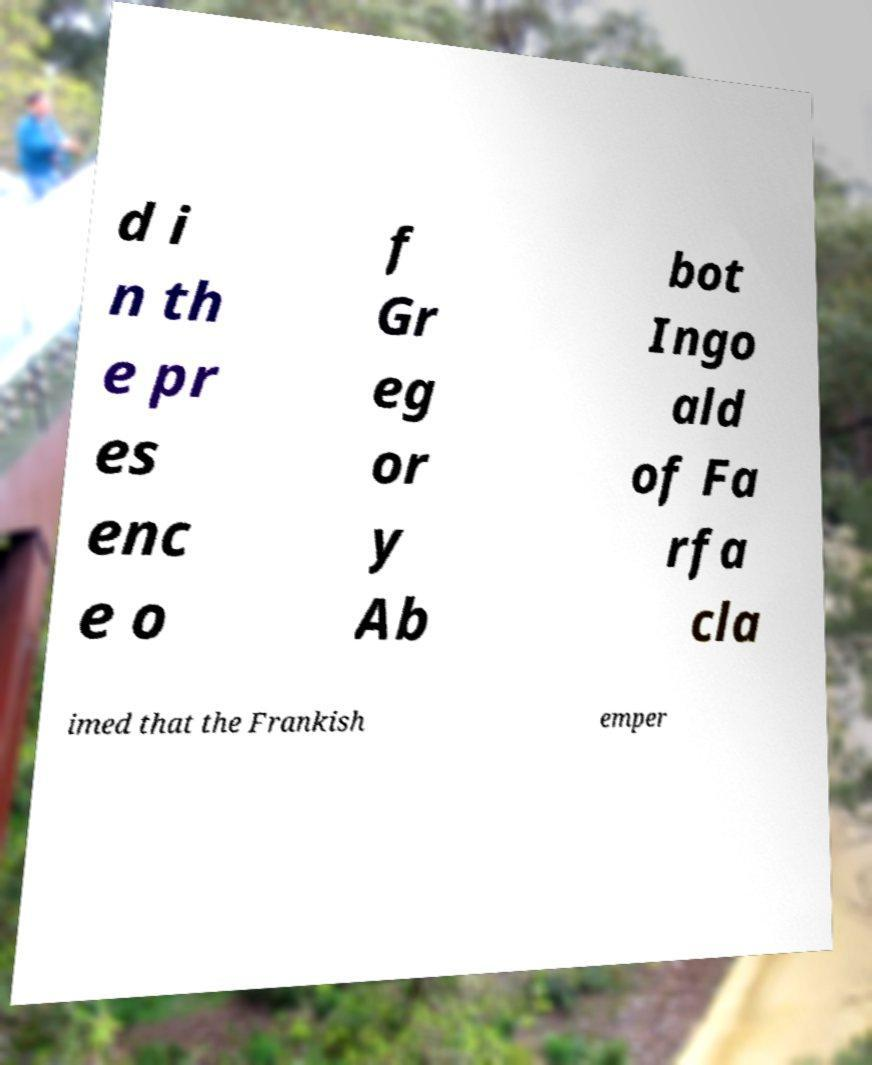For documentation purposes, I need the text within this image transcribed. Could you provide that? d i n th e pr es enc e o f Gr eg or y Ab bot Ingo ald of Fa rfa cla imed that the Frankish emper 